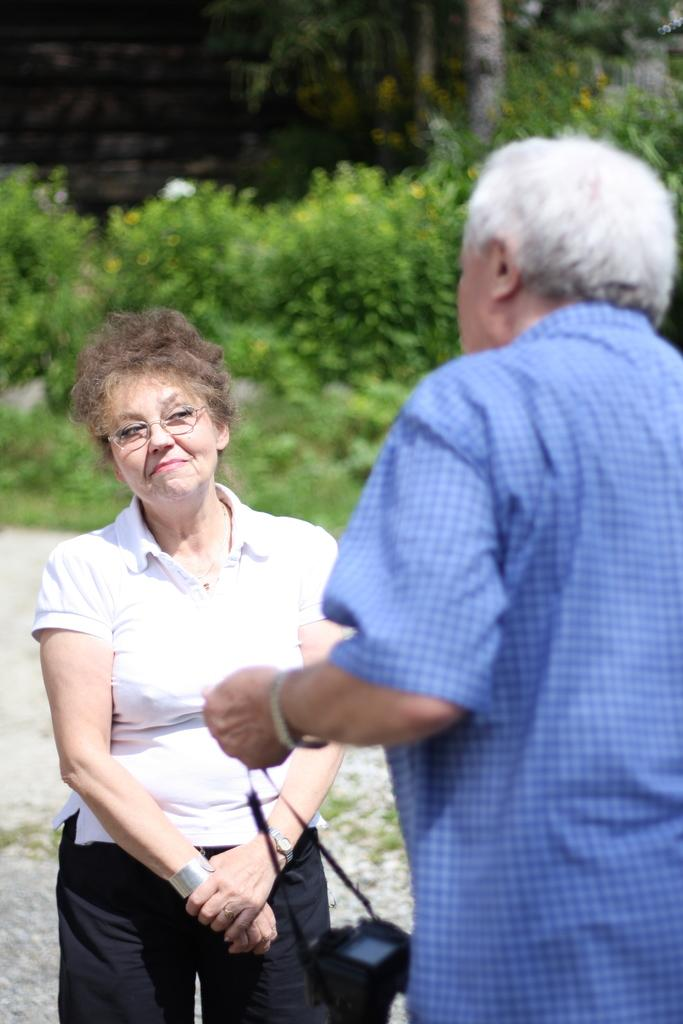How many people are in the image? There are two people in the image, a man and a woman. What are the positions of the man and woman in the image? The man and woman are both standing in the image. What is the man holding in the image? The man is holding a camera in the image. What can be seen in the background of the image? There are plants and trees in the background of the image. What is the rate of the fan in the image? There is no fan present in the image, so it is not possible to determine its rate. 